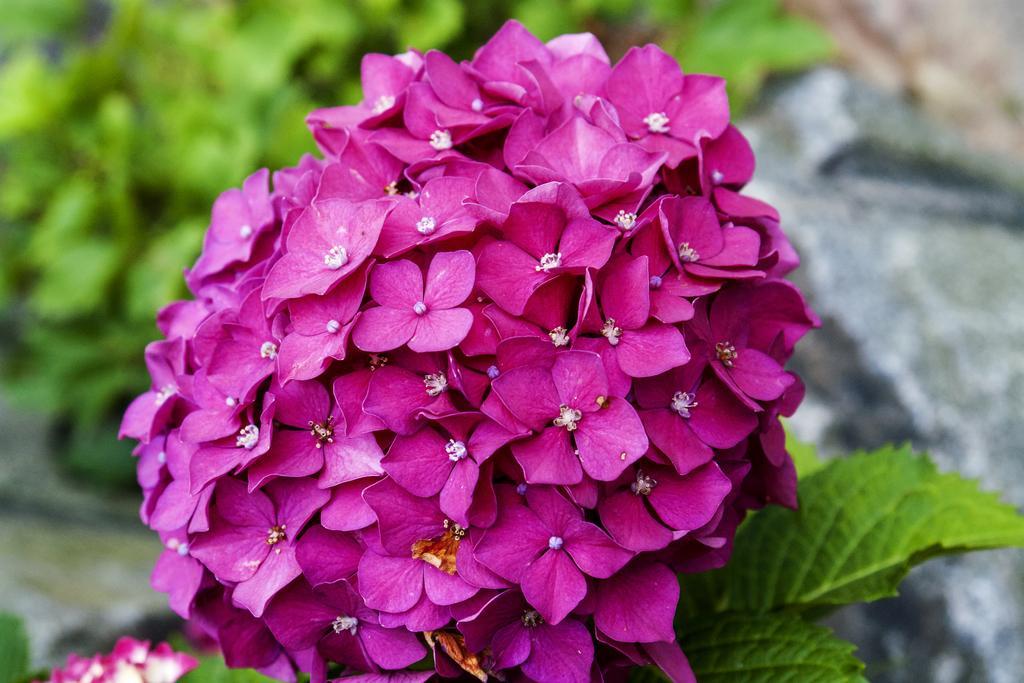Please provide a concise description of this image. In this picture we can see flowers and leaves. There is a blur background. 